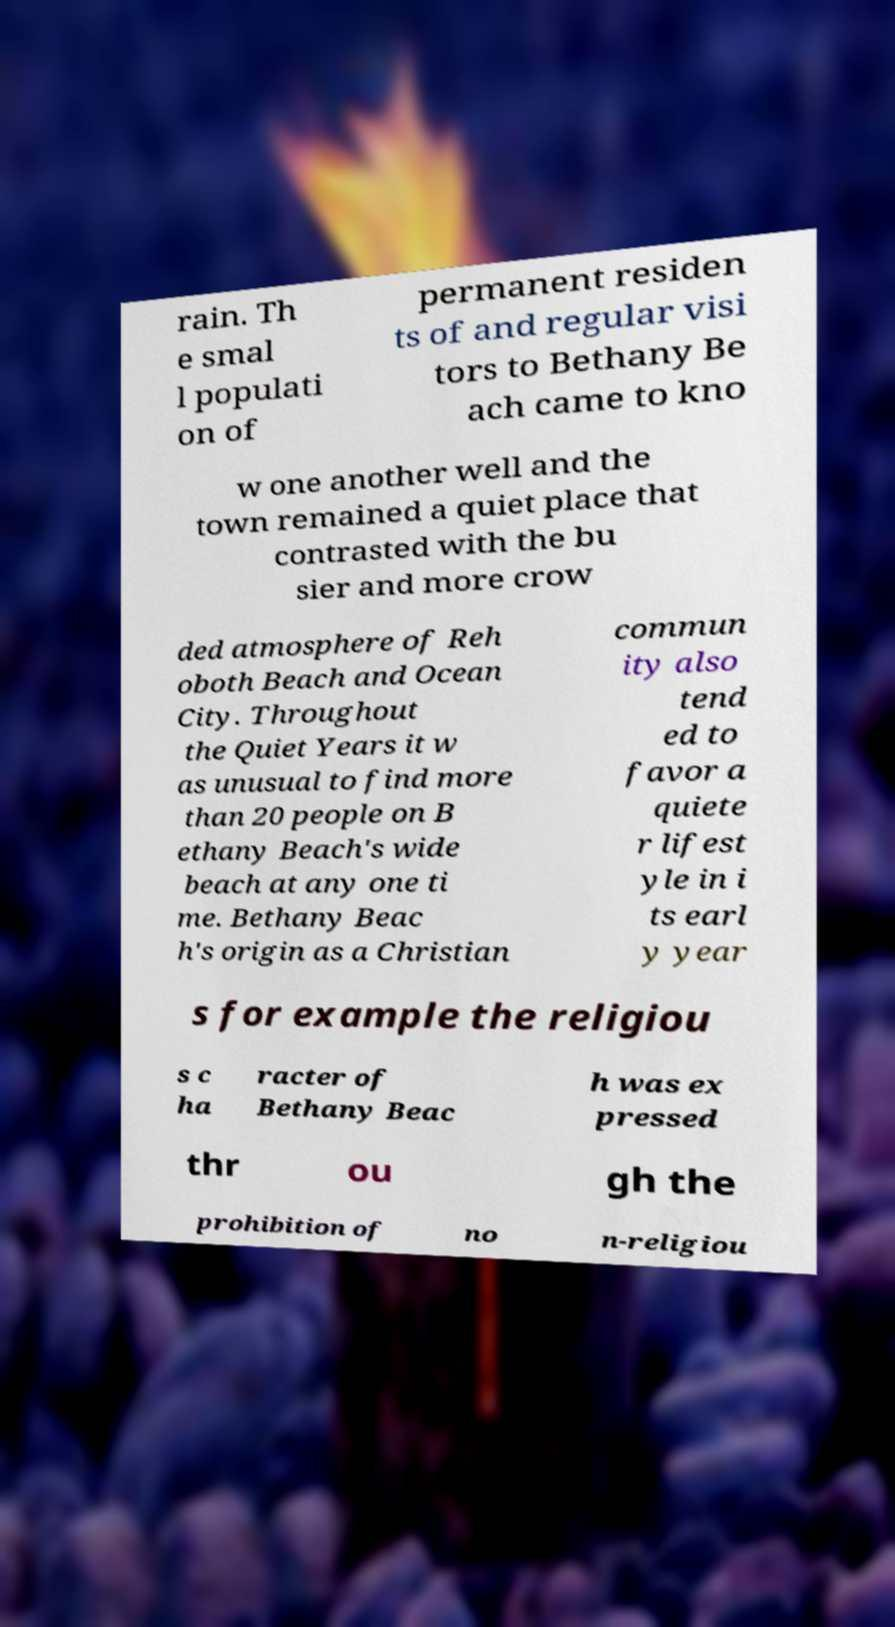Please read and relay the text visible in this image. What does it say? rain. Th e smal l populati on of permanent residen ts of and regular visi tors to Bethany Be ach came to kno w one another well and the town remained a quiet place that contrasted with the bu sier and more crow ded atmosphere of Reh oboth Beach and Ocean City. Throughout the Quiet Years it w as unusual to find more than 20 people on B ethany Beach's wide beach at any one ti me. Bethany Beac h's origin as a Christian commun ity also tend ed to favor a quiete r lifest yle in i ts earl y year s for example the religiou s c ha racter of Bethany Beac h was ex pressed thr ou gh the prohibition of no n-religiou 